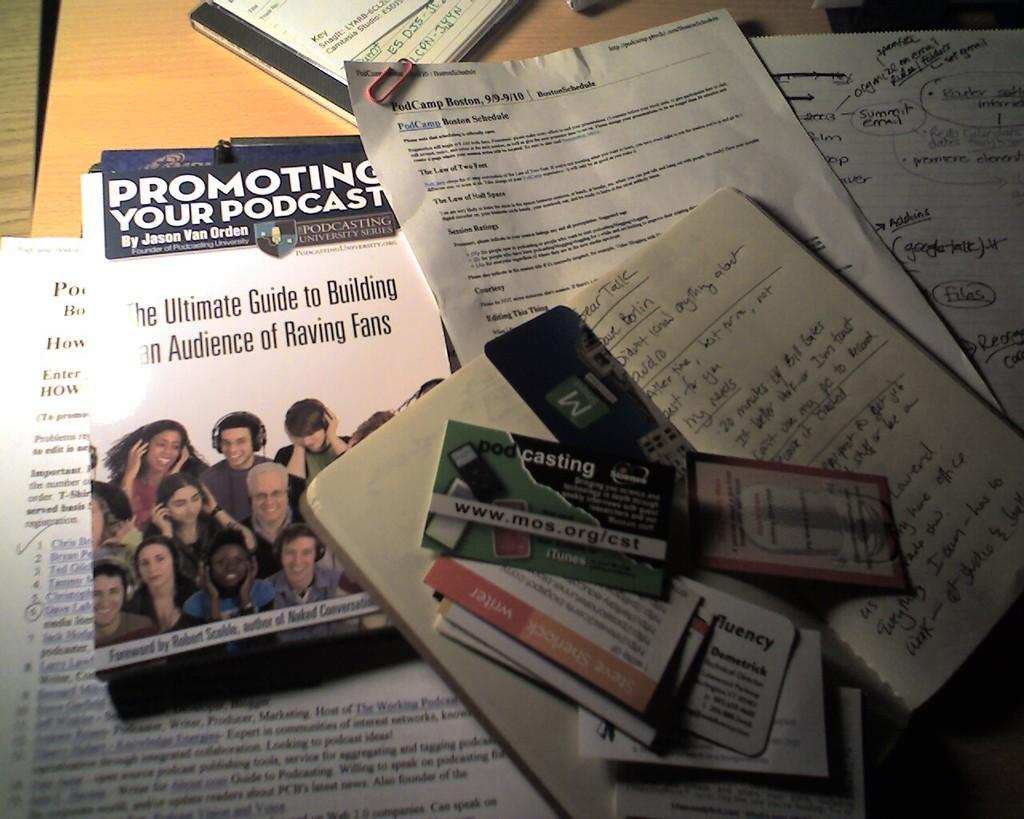<image>
Write a terse but informative summary of the picture. Promoting your podcast pamphlet, cards, papers, and handwritten notes.. 